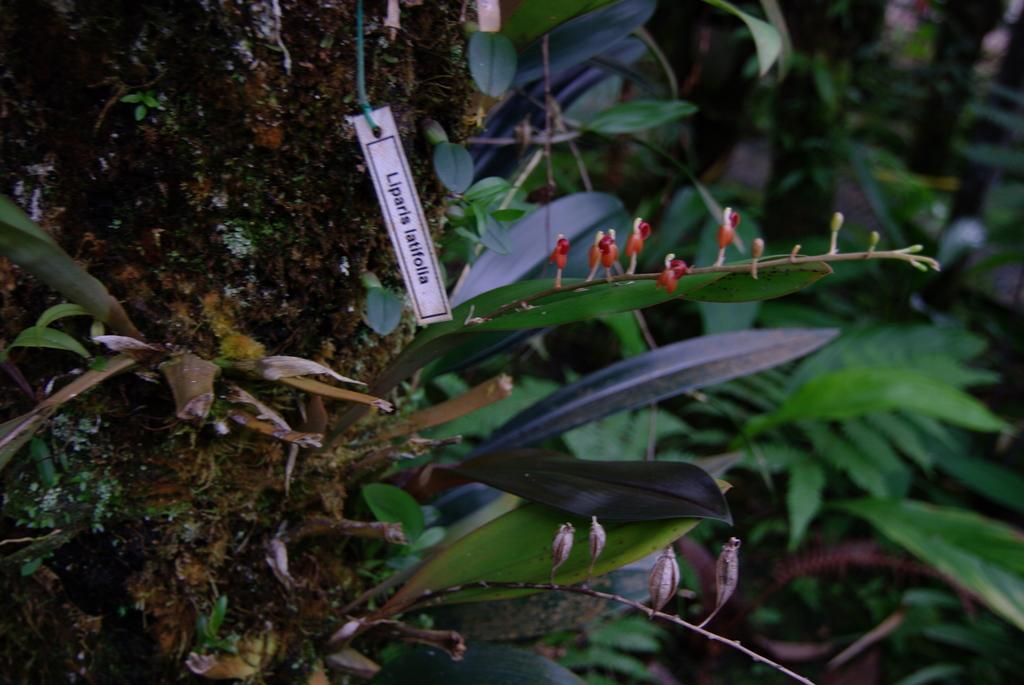What type of living organisms can be seen in the image? Plants can be seen in the image. What stage of growth are the plants in? There are buds on the plants, indicating that they are in the early stages of growth. Is there any additional information provided about the plants? Yes, there is a tag associated with the plants. What type of steel is used to make the page in the image? There is no page or steel present in the image; it features plants with buds and a tag. 